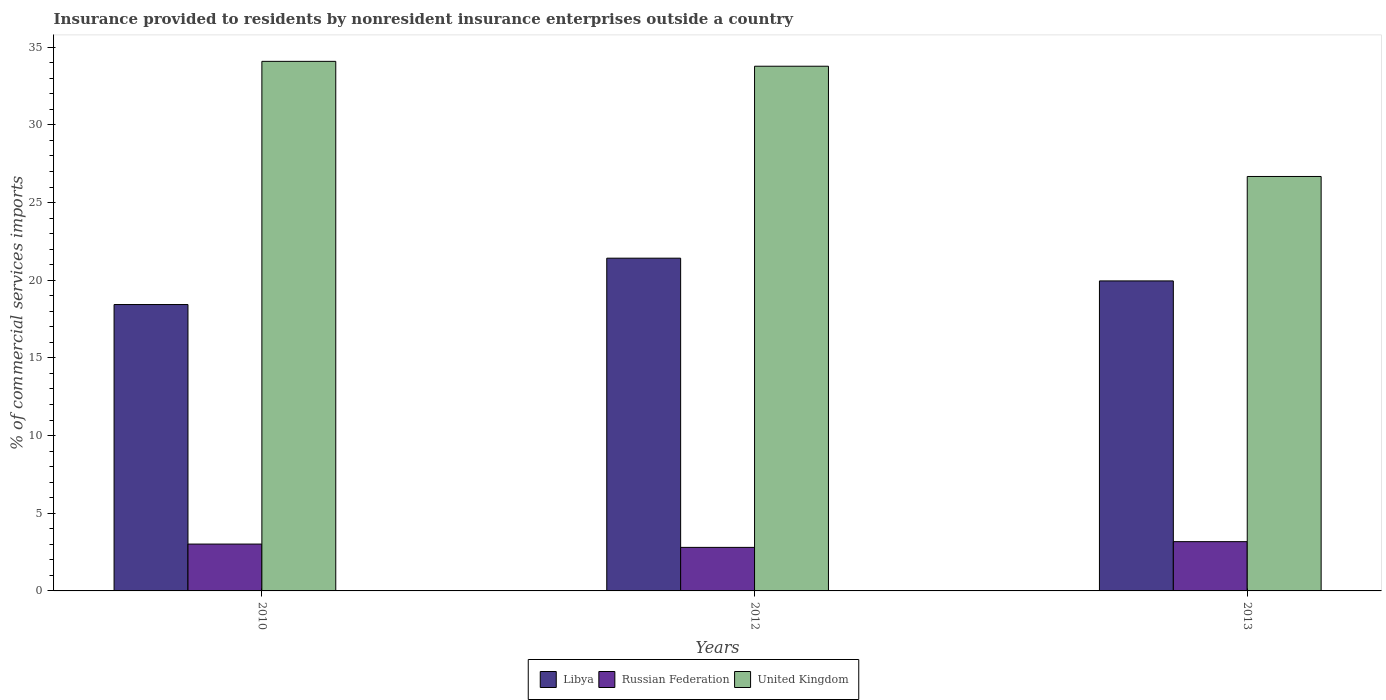Are the number of bars per tick equal to the number of legend labels?
Give a very brief answer. Yes. Are the number of bars on each tick of the X-axis equal?
Make the answer very short. Yes. What is the label of the 3rd group of bars from the left?
Your answer should be very brief. 2013. In how many cases, is the number of bars for a given year not equal to the number of legend labels?
Offer a terse response. 0. What is the Insurance provided to residents in United Kingdom in 2013?
Ensure brevity in your answer.  26.68. Across all years, what is the maximum Insurance provided to residents in Russian Federation?
Offer a very short reply. 3.17. Across all years, what is the minimum Insurance provided to residents in Libya?
Your answer should be compact. 18.43. In which year was the Insurance provided to residents in Russian Federation minimum?
Your response must be concise. 2012. What is the total Insurance provided to residents in Libya in the graph?
Keep it short and to the point. 59.81. What is the difference between the Insurance provided to residents in Libya in 2012 and that in 2013?
Keep it short and to the point. 1.46. What is the difference between the Insurance provided to residents in Russian Federation in 2012 and the Insurance provided to residents in United Kingdom in 2013?
Your answer should be very brief. -23.88. What is the average Insurance provided to residents in Libya per year?
Provide a short and direct response. 19.94. In the year 2013, what is the difference between the Insurance provided to residents in United Kingdom and Insurance provided to residents in Libya?
Ensure brevity in your answer.  6.72. In how many years, is the Insurance provided to residents in United Kingdom greater than 11 %?
Give a very brief answer. 3. What is the ratio of the Insurance provided to residents in Russian Federation in 2010 to that in 2012?
Provide a succinct answer. 1.08. What is the difference between the highest and the second highest Insurance provided to residents in United Kingdom?
Keep it short and to the point. 0.31. What is the difference between the highest and the lowest Insurance provided to residents in Libya?
Offer a terse response. 2.98. Is the sum of the Insurance provided to residents in Russian Federation in 2010 and 2012 greater than the maximum Insurance provided to residents in Libya across all years?
Offer a very short reply. No. What does the 2nd bar from the left in 2013 represents?
Ensure brevity in your answer.  Russian Federation. What does the 2nd bar from the right in 2010 represents?
Provide a succinct answer. Russian Federation. How many bars are there?
Provide a short and direct response. 9. Are all the bars in the graph horizontal?
Keep it short and to the point. No. Does the graph contain any zero values?
Offer a terse response. No. Does the graph contain grids?
Give a very brief answer. No. Where does the legend appear in the graph?
Give a very brief answer. Bottom center. How are the legend labels stacked?
Provide a short and direct response. Horizontal. What is the title of the graph?
Give a very brief answer. Insurance provided to residents by nonresident insurance enterprises outside a country. What is the label or title of the Y-axis?
Your answer should be very brief. % of commercial services imports. What is the % of commercial services imports of Libya in 2010?
Provide a succinct answer. 18.43. What is the % of commercial services imports in Russian Federation in 2010?
Provide a succinct answer. 3.02. What is the % of commercial services imports in United Kingdom in 2010?
Offer a very short reply. 34.09. What is the % of commercial services imports of Libya in 2012?
Offer a very short reply. 21.42. What is the % of commercial services imports in Russian Federation in 2012?
Provide a succinct answer. 2.8. What is the % of commercial services imports in United Kingdom in 2012?
Make the answer very short. 33.77. What is the % of commercial services imports in Libya in 2013?
Ensure brevity in your answer.  19.96. What is the % of commercial services imports of Russian Federation in 2013?
Your answer should be compact. 3.17. What is the % of commercial services imports of United Kingdom in 2013?
Your answer should be compact. 26.68. Across all years, what is the maximum % of commercial services imports of Libya?
Your response must be concise. 21.42. Across all years, what is the maximum % of commercial services imports in Russian Federation?
Provide a short and direct response. 3.17. Across all years, what is the maximum % of commercial services imports in United Kingdom?
Your answer should be very brief. 34.09. Across all years, what is the minimum % of commercial services imports of Libya?
Offer a terse response. 18.43. Across all years, what is the minimum % of commercial services imports in Russian Federation?
Offer a very short reply. 2.8. Across all years, what is the minimum % of commercial services imports in United Kingdom?
Give a very brief answer. 26.68. What is the total % of commercial services imports of Libya in the graph?
Keep it short and to the point. 59.81. What is the total % of commercial services imports of Russian Federation in the graph?
Make the answer very short. 8.99. What is the total % of commercial services imports in United Kingdom in the graph?
Your response must be concise. 94.54. What is the difference between the % of commercial services imports in Libya in 2010 and that in 2012?
Offer a terse response. -2.98. What is the difference between the % of commercial services imports in Russian Federation in 2010 and that in 2012?
Ensure brevity in your answer.  0.21. What is the difference between the % of commercial services imports of United Kingdom in 2010 and that in 2012?
Provide a short and direct response. 0.31. What is the difference between the % of commercial services imports of Libya in 2010 and that in 2013?
Offer a very short reply. -1.52. What is the difference between the % of commercial services imports in Russian Federation in 2010 and that in 2013?
Offer a very short reply. -0.16. What is the difference between the % of commercial services imports of United Kingdom in 2010 and that in 2013?
Your answer should be very brief. 7.41. What is the difference between the % of commercial services imports in Libya in 2012 and that in 2013?
Offer a very short reply. 1.46. What is the difference between the % of commercial services imports of Russian Federation in 2012 and that in 2013?
Provide a short and direct response. -0.37. What is the difference between the % of commercial services imports of United Kingdom in 2012 and that in 2013?
Ensure brevity in your answer.  7.1. What is the difference between the % of commercial services imports in Libya in 2010 and the % of commercial services imports in Russian Federation in 2012?
Provide a short and direct response. 15.63. What is the difference between the % of commercial services imports of Libya in 2010 and the % of commercial services imports of United Kingdom in 2012?
Provide a succinct answer. -15.34. What is the difference between the % of commercial services imports in Russian Federation in 2010 and the % of commercial services imports in United Kingdom in 2012?
Your answer should be very brief. -30.76. What is the difference between the % of commercial services imports in Libya in 2010 and the % of commercial services imports in Russian Federation in 2013?
Your response must be concise. 15.26. What is the difference between the % of commercial services imports in Libya in 2010 and the % of commercial services imports in United Kingdom in 2013?
Give a very brief answer. -8.24. What is the difference between the % of commercial services imports of Russian Federation in 2010 and the % of commercial services imports of United Kingdom in 2013?
Offer a very short reply. -23.66. What is the difference between the % of commercial services imports in Libya in 2012 and the % of commercial services imports in Russian Federation in 2013?
Keep it short and to the point. 18.25. What is the difference between the % of commercial services imports of Libya in 2012 and the % of commercial services imports of United Kingdom in 2013?
Offer a very short reply. -5.26. What is the difference between the % of commercial services imports in Russian Federation in 2012 and the % of commercial services imports in United Kingdom in 2013?
Your response must be concise. -23.88. What is the average % of commercial services imports in Libya per year?
Your answer should be very brief. 19.94. What is the average % of commercial services imports of Russian Federation per year?
Keep it short and to the point. 3. What is the average % of commercial services imports of United Kingdom per year?
Give a very brief answer. 31.51. In the year 2010, what is the difference between the % of commercial services imports of Libya and % of commercial services imports of Russian Federation?
Ensure brevity in your answer.  15.42. In the year 2010, what is the difference between the % of commercial services imports of Libya and % of commercial services imports of United Kingdom?
Give a very brief answer. -15.65. In the year 2010, what is the difference between the % of commercial services imports in Russian Federation and % of commercial services imports in United Kingdom?
Ensure brevity in your answer.  -31.07. In the year 2012, what is the difference between the % of commercial services imports in Libya and % of commercial services imports in Russian Federation?
Offer a very short reply. 18.62. In the year 2012, what is the difference between the % of commercial services imports of Libya and % of commercial services imports of United Kingdom?
Keep it short and to the point. -12.36. In the year 2012, what is the difference between the % of commercial services imports of Russian Federation and % of commercial services imports of United Kingdom?
Ensure brevity in your answer.  -30.97. In the year 2013, what is the difference between the % of commercial services imports in Libya and % of commercial services imports in Russian Federation?
Offer a very short reply. 16.78. In the year 2013, what is the difference between the % of commercial services imports in Libya and % of commercial services imports in United Kingdom?
Offer a terse response. -6.72. In the year 2013, what is the difference between the % of commercial services imports of Russian Federation and % of commercial services imports of United Kingdom?
Provide a short and direct response. -23.51. What is the ratio of the % of commercial services imports of Libya in 2010 to that in 2012?
Offer a terse response. 0.86. What is the ratio of the % of commercial services imports in Russian Federation in 2010 to that in 2012?
Your answer should be compact. 1.08. What is the ratio of the % of commercial services imports in United Kingdom in 2010 to that in 2012?
Provide a short and direct response. 1.01. What is the ratio of the % of commercial services imports of Libya in 2010 to that in 2013?
Keep it short and to the point. 0.92. What is the ratio of the % of commercial services imports of Russian Federation in 2010 to that in 2013?
Your answer should be very brief. 0.95. What is the ratio of the % of commercial services imports in United Kingdom in 2010 to that in 2013?
Make the answer very short. 1.28. What is the ratio of the % of commercial services imports of Libya in 2012 to that in 2013?
Offer a terse response. 1.07. What is the ratio of the % of commercial services imports of Russian Federation in 2012 to that in 2013?
Offer a very short reply. 0.88. What is the ratio of the % of commercial services imports in United Kingdom in 2012 to that in 2013?
Provide a succinct answer. 1.27. What is the difference between the highest and the second highest % of commercial services imports of Libya?
Your answer should be very brief. 1.46. What is the difference between the highest and the second highest % of commercial services imports of Russian Federation?
Offer a very short reply. 0.16. What is the difference between the highest and the second highest % of commercial services imports in United Kingdom?
Ensure brevity in your answer.  0.31. What is the difference between the highest and the lowest % of commercial services imports of Libya?
Provide a succinct answer. 2.98. What is the difference between the highest and the lowest % of commercial services imports in Russian Federation?
Ensure brevity in your answer.  0.37. What is the difference between the highest and the lowest % of commercial services imports in United Kingdom?
Ensure brevity in your answer.  7.41. 